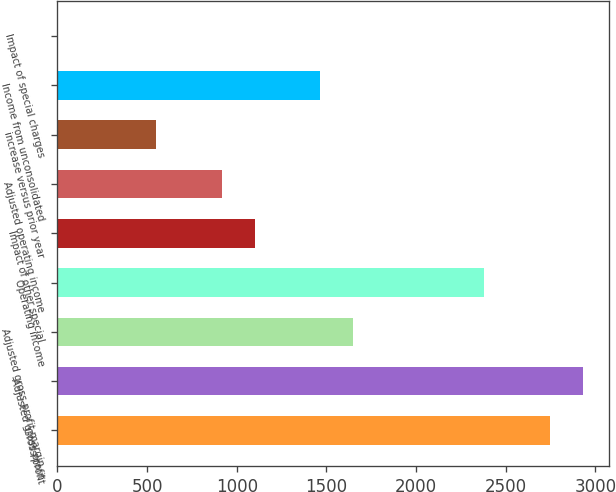Convert chart. <chart><loc_0><loc_0><loc_500><loc_500><bar_chart><fcel>Gross profit<fcel>Adjusted gross profit<fcel>Adjusted gross profit margin<fcel>Operating income<fcel>Impact of other special<fcel>Adjusted operating income<fcel>increase versus prior year<fcel>Income from unconsolidated<fcel>Impact of special charges<nl><fcel>2746.65<fcel>2929.58<fcel>1649.07<fcel>2380.79<fcel>1100.28<fcel>917.35<fcel>551.49<fcel>1466.14<fcel>2.7<nl></chart> 